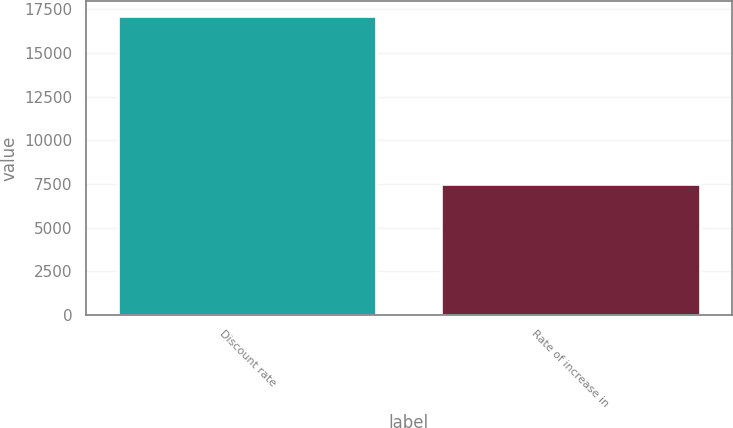Convert chart. <chart><loc_0><loc_0><loc_500><loc_500><bar_chart><fcel>Discount rate<fcel>Rate of increase in<nl><fcel>17145<fcel>7503<nl></chart> 